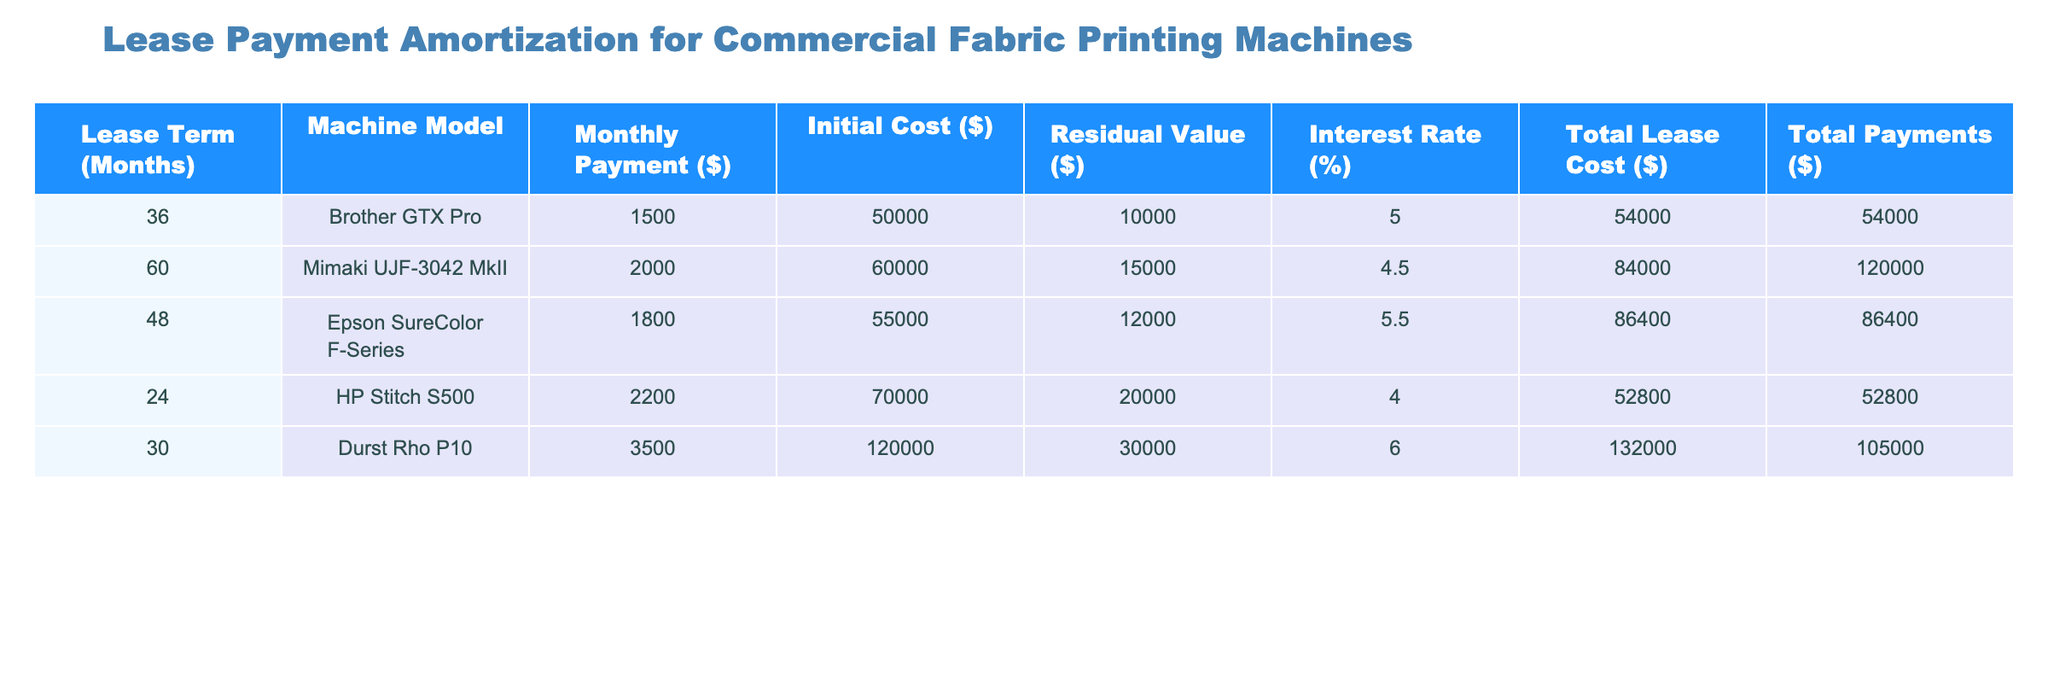What is the monthly payment for the Brother GTX Pro? The monthly payment is listed directly under the column for monthly payments for the Brother GTX Pro, which shows $1500.
Answer: 1500 What is the total lease cost for the Mimaki UJF-3042 MkII? The total lease cost is present under the column labeled Total Lease Cost for the Mimaki UJF-3042 MkII, which is $84000.
Answer: 84000 Which machine model has the highest initial cost? By comparing the initial costs of all machines, the Durst Rho P10 has the highest initial cost at $120000.
Answer: Durst Rho P10 Is the residual value for the HP Stitch S500 greater than $15000? The residual value for the HP Stitch S500 is $20000, which is greater than $15000.
Answer: Yes What is the average monthly payment across all machines? To find the average, sum the monthly payments ($1500 + $2000 + $1800 + $2200 + $3500 = $11000) and divide by the number of machines (5). The average is $11000 / 5 = $2200.
Answer: 2200 What is the total cost difference between the Epson SureColor F-Series and the Brother GTX Pro? Calculate the total costs for both machines ($86400 for Epson SureColor and $54000 for Brother GTX Pro) and find the difference: $86400 - $54000 = $32400.
Answer: 32400 Does the Mimaki UJF-3042 MkII have a longer lease term than the HP Stitch S500? The Mimaki UJF-3042 MkII has a lease term of 60 months, while the HP Stitch S500 has a lease term of 24 months, so 60 months is longer.
Answer: Yes What is the total of all residual values for the machines? Adding the residual values ($10000 + $15000 + $12000 + $20000 + $30000 = $87000) gives a total of $87000.
Answer: 87000 How many machines have a monthly payment greater than $2000? The machines with monthly payments greater than $2000 are Mimaki UJF-3042 MkII ($2000), HP Stitch S500 ($2200), and Durst Rho P10 ($3500), totaling three machines.
Answer: 3 